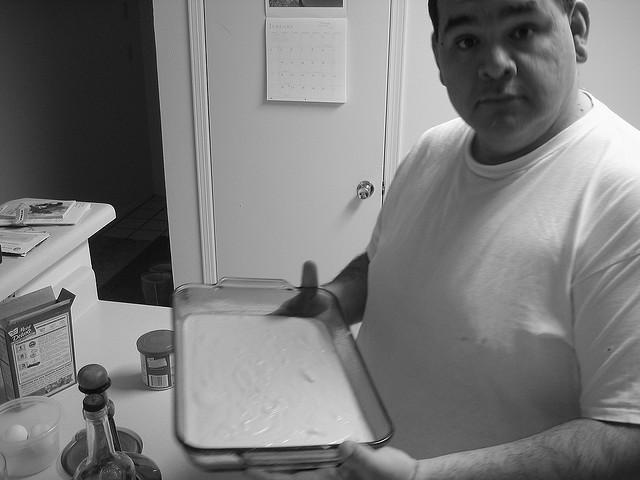Is this person emptying a parking meter?
Answer briefly. No. Why is the man holding his nose?
Give a very brief answer. He's not. Is he cooking?
Short answer required. Yes. Where is the man looking?
Keep it brief. Camera. Did he eat all of it?
Keep it brief. No. What is the mans current emotion?
Quick response, please. Happy. Is the person young?
Be succinct. No. What color is his shirt?
Answer briefly. White. Is this man a professional cook?
Keep it brief. No. What color is the photo?
Quick response, please. Black and white. Is the man playing a video game?
Quick response, please. No. Is he wearing glasses?
Be succinct. No. What do you feel when this food is eaten?
Answer briefly. Full. What is the man doing?
Short answer required. Baking. How many plates?
Keep it brief. 0. Is this person holding a smart device?
Keep it brief. No. Where are the magazines in this picture?
Write a very short answer. Counter. 